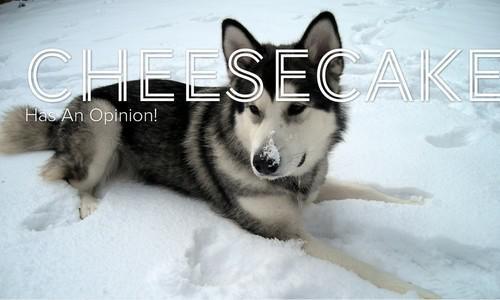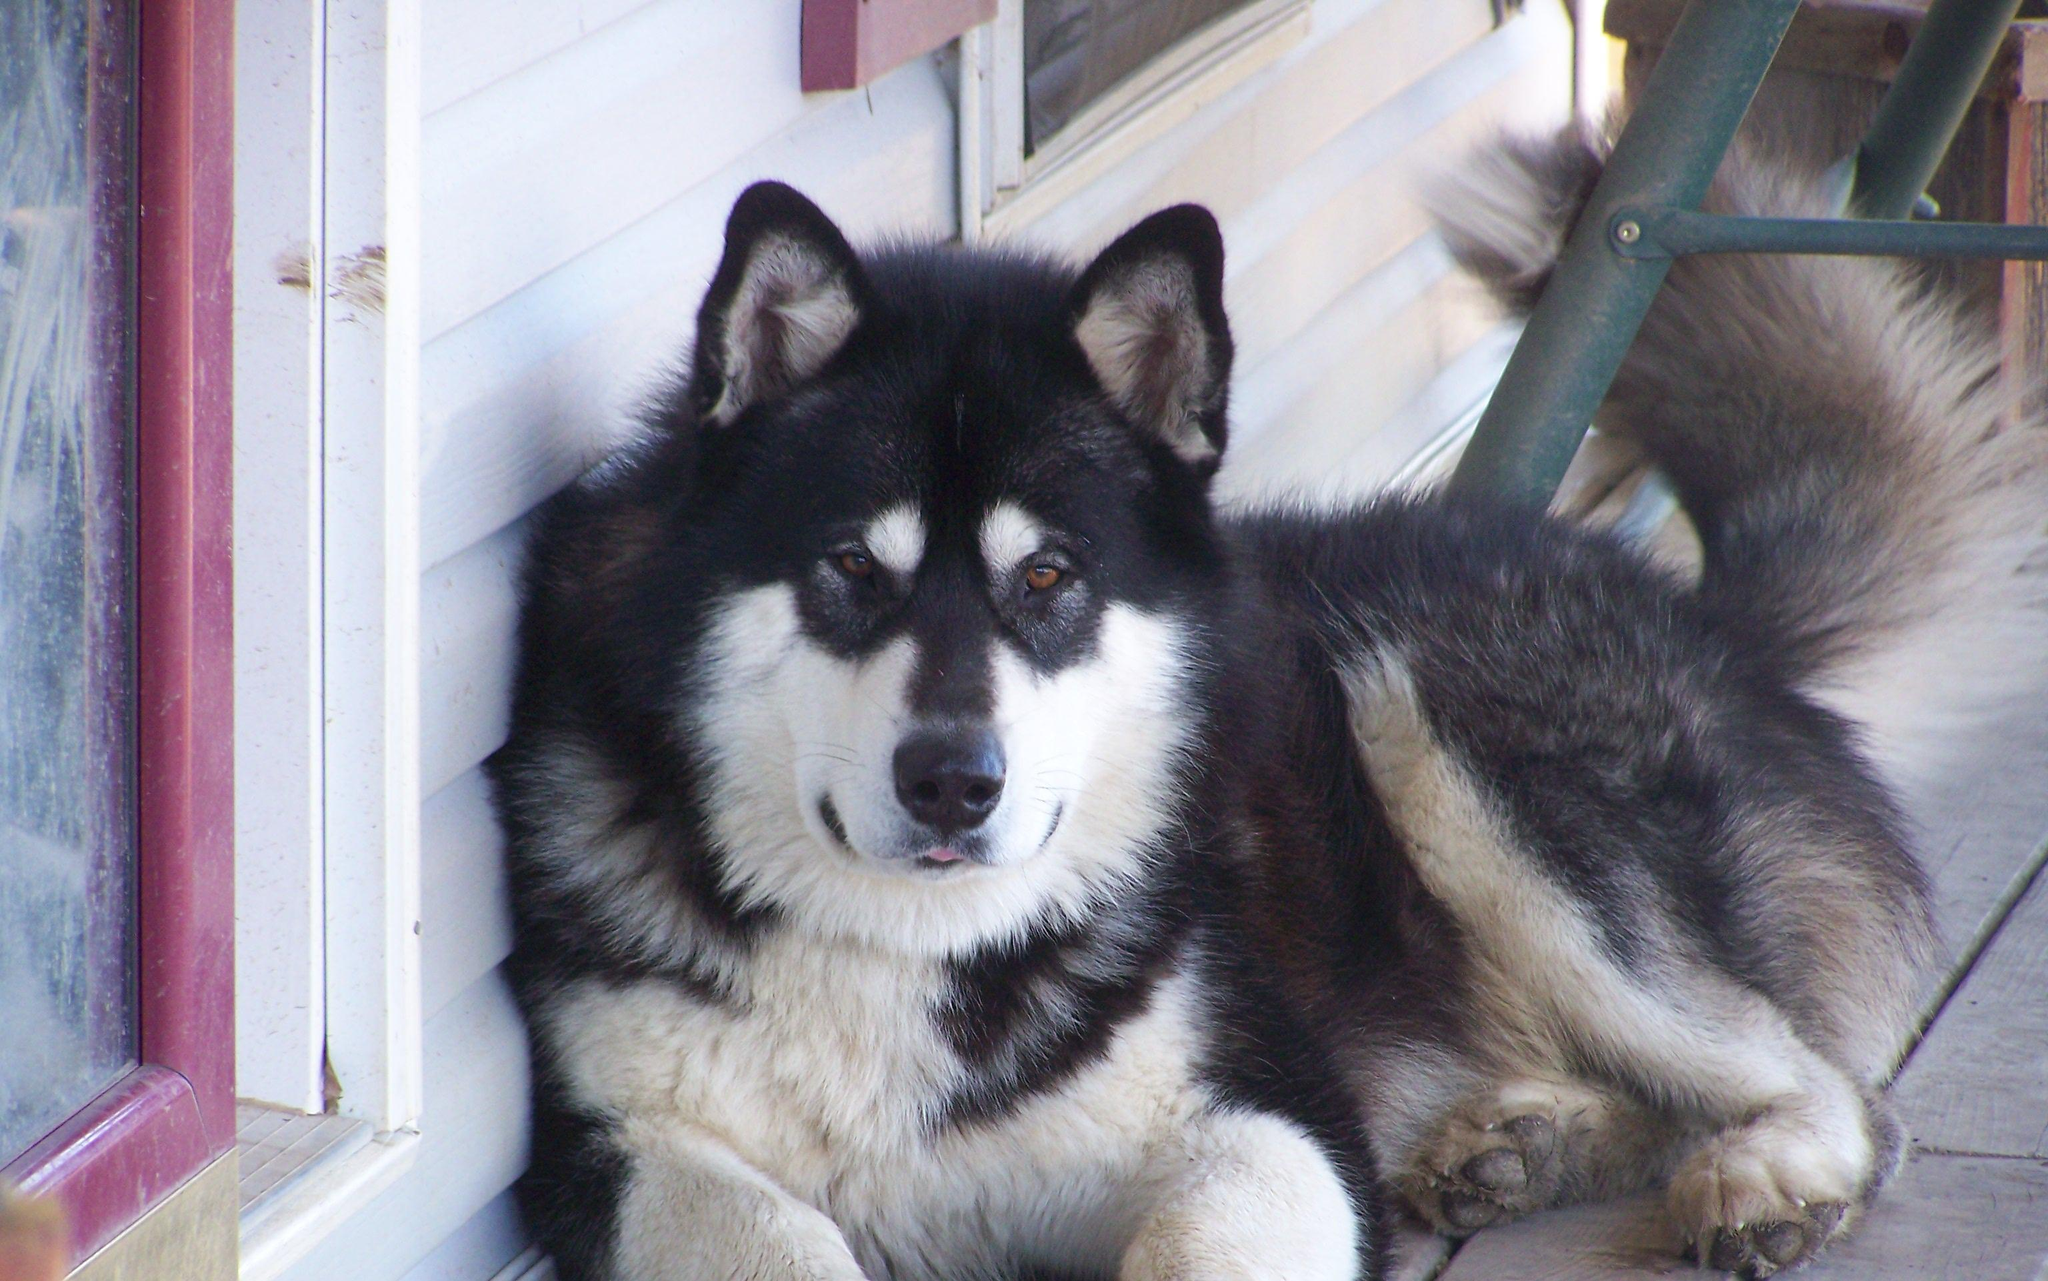The first image is the image on the left, the second image is the image on the right. For the images displayed, is the sentence "The left image features one non-reclining dog with snow on its face, and the right image includes at least one forward-facing dog with its tongue hanging down." factually correct? Answer yes or no. No. The first image is the image on the left, the second image is the image on the right. Assess this claim about the two images: "There are exactly two dogs posing in a snowy environment.". Correct or not? Answer yes or no. No. 